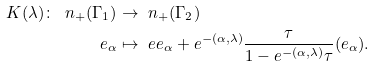<formula> <loc_0><loc_0><loc_500><loc_500>K ( \lambda ) \colon \ n _ { + } ( { \Gamma _ { 1 } } ) & \to \ n _ { + } ( { \Gamma _ { 2 } } ) \\ e _ { \alpha } & \mapsto \ e e _ { \alpha } + e ^ { - ( \alpha , \lambda ) } \frac { \tau } { 1 - e ^ { - ( \alpha , \lambda ) } \tau } ( e _ { \alpha } ) .</formula> 